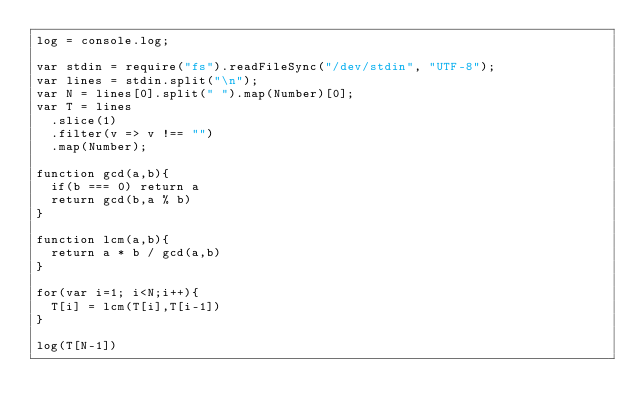Convert code to text. <code><loc_0><loc_0><loc_500><loc_500><_JavaScript_>log = console.log;

var stdin = require("fs").readFileSync("/dev/stdin", "UTF-8");
var lines = stdin.split("\n");
var N = lines[0].split(" ").map(Number)[0];
var T = lines
  .slice(1)
  .filter(v => v !== "")
  .map(Number);

function gcd(a,b){
  if(b === 0) return a
  return gcd(b,a % b)
}

function lcm(a,b){
  return a * b / gcd(a,b)
}

for(var i=1; i<N;i++){
  T[i] = lcm(T[i],T[i-1])
}

log(T[N-1])</code> 